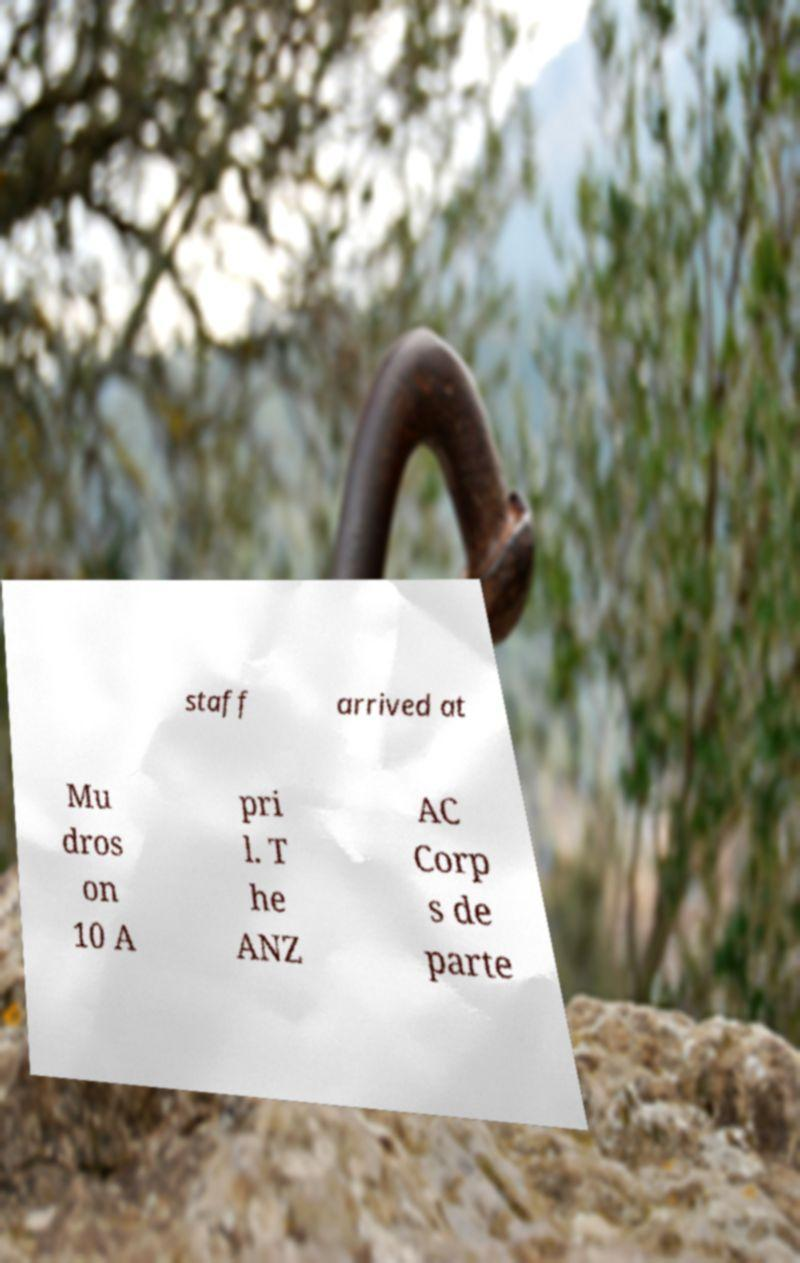For documentation purposes, I need the text within this image transcribed. Could you provide that? staff arrived at Mu dros on 10 A pri l. T he ANZ AC Corp s de parte 